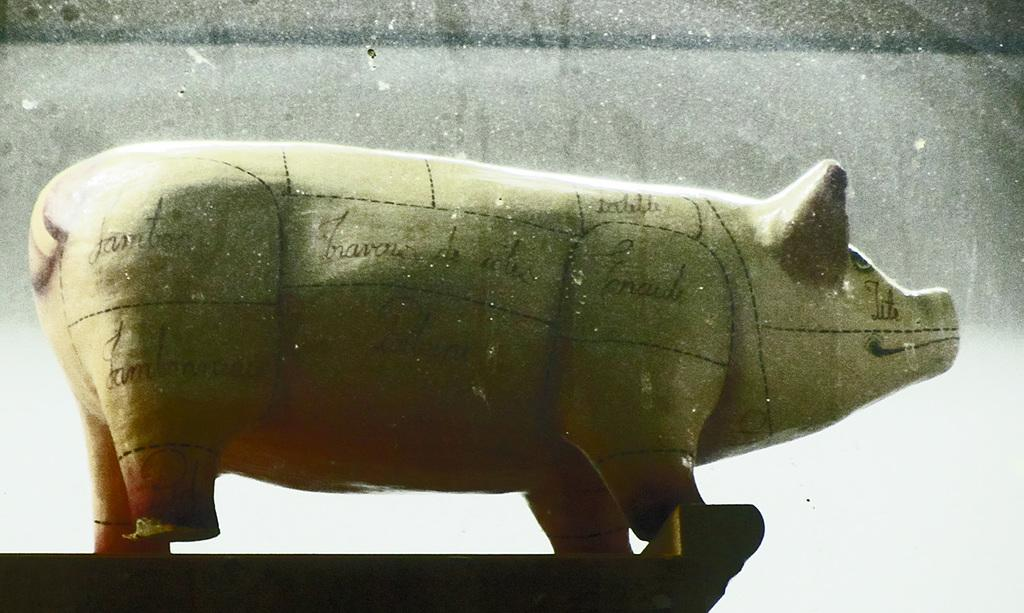What is the main subject in the foreground of the image? There is a model of a pig in the foreground of the image. Can you describe the position or location of the model of the pig in the image? The model of the pig is on a surface. What type of can does the toad use to carry the pig model in the image? There is no toad or can present in the image. 